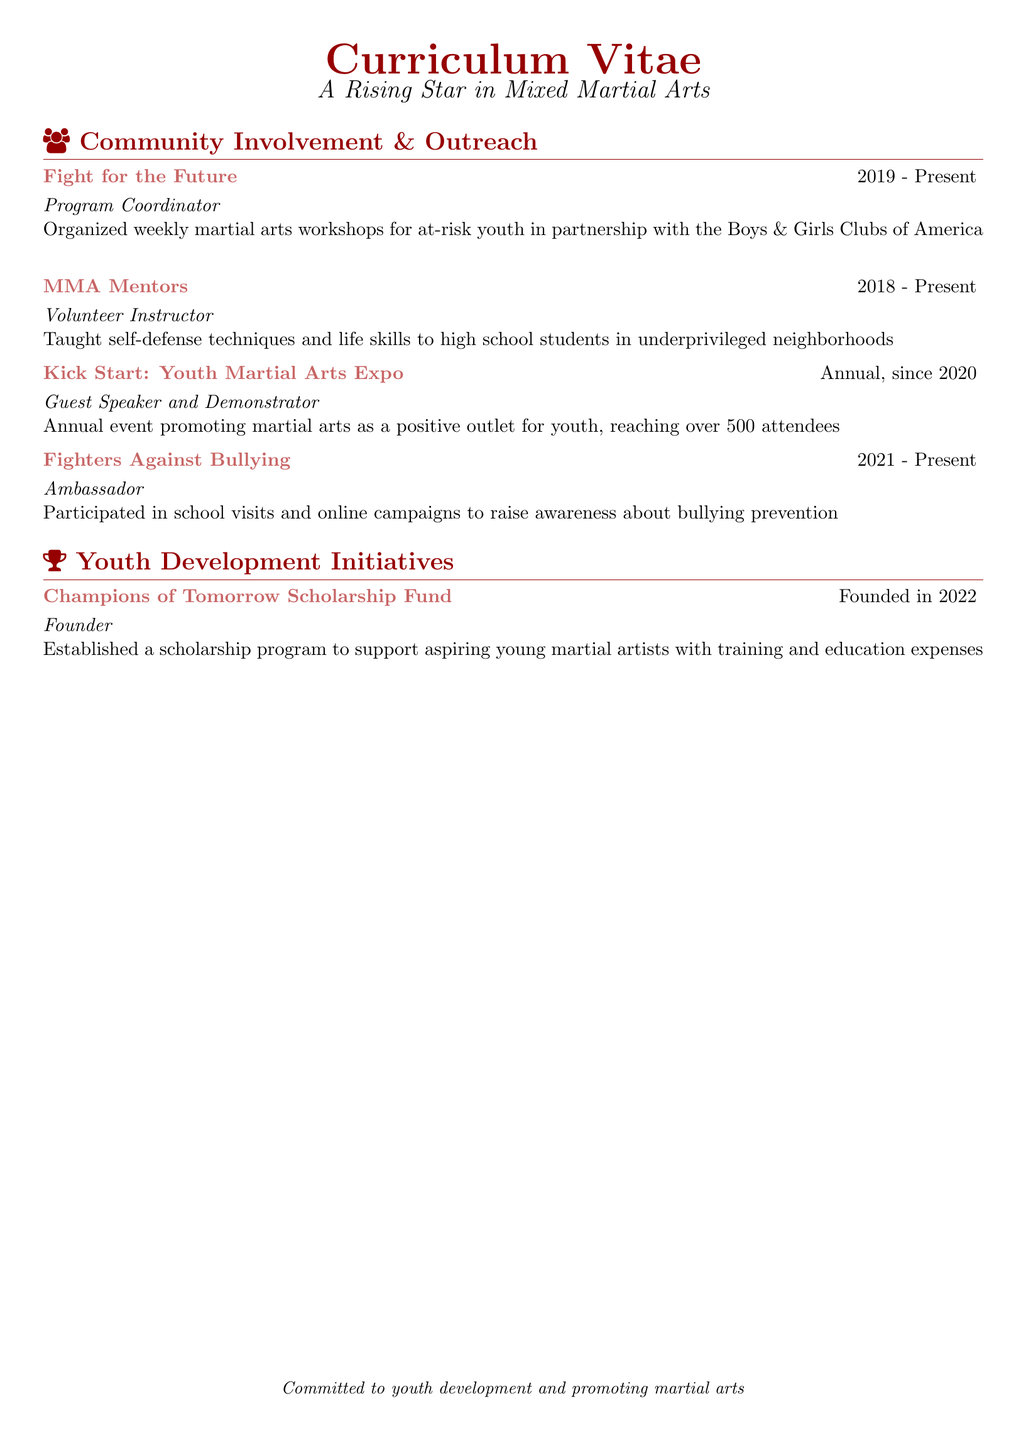what is the name of the program where the fighter organized workshops? The program where the fighter organized workshops is titled "Fight for the Future."
Answer: Fight for the Future what is the duration of the MMA Mentors program? The duration of the MMA Mentors program is from 2018 to Present.
Answer: 2018 - Present how often is the Kick Start event held? The Kick Start event is held annually, since 2020.
Answer: Annual who is the ambassador for Fighters Against Bullying? The fighter serves as the ambassador for Fighters Against Bullying.
Answer: Fighter what year was the Champions of Tomorrow Scholarship Fund founded? The Champions of Tomorrow Scholarship Fund was founded in 2022.
Answer: 2022 what role does the fighter play in the Fight for the Future program? The fighter is the Program Coordinator in the Fight for the Future program.
Answer: Program Coordinator how many attendees does the Kick Start event reach? The Kick Start event reaches over 500 attendees.
Answer: over 500 what type of skills does the MMA Mentors program focus on teaching? The MMA Mentors program focuses on teaching self-defense techniques and life skills.
Answer: self-defense techniques and life skills what is a primary goal of the Champions of Tomorrow Scholarship Fund? The primary goal of the Champions of Tomorrow Scholarship Fund is to support aspiring young martial artists.
Answer: support aspiring young martial artists 